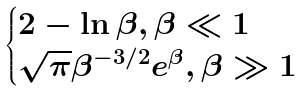<formula> <loc_0><loc_0><loc_500><loc_500>\begin{cases} 2 - \ln \beta , \beta \ll 1 \\ \sqrt { \pi } \beta ^ { - 3 / 2 } e ^ { \beta } , \beta \gg 1 \end{cases}</formula> 